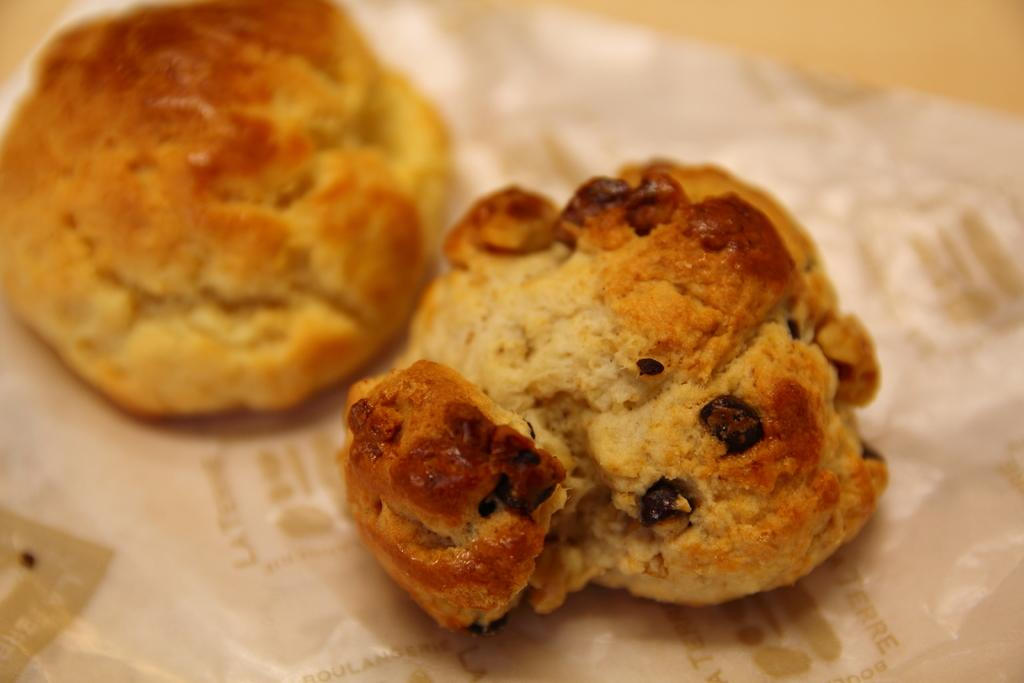What type of food can be seen in the image? There are cookies in the image. Where are the cookies located? The cookies are placed on a table. What type of cake can be seen in the alley in the image? There is no cake or alley present in the image; it only features cookies placed on a table. 